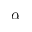Convert formula to latex. <formula><loc_0><loc_0><loc_500><loc_500>\alpha</formula> 